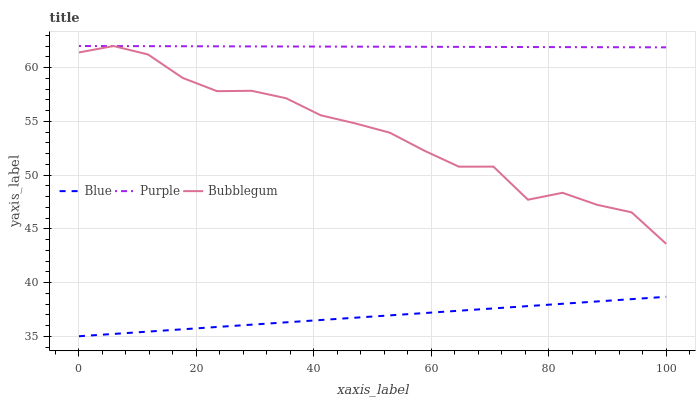Does Bubblegum have the minimum area under the curve?
Answer yes or no. No. Does Bubblegum have the maximum area under the curve?
Answer yes or no. No. Is Bubblegum the smoothest?
Answer yes or no. No. Is Purple the roughest?
Answer yes or no. No. Does Bubblegum have the lowest value?
Answer yes or no. No. Is Blue less than Purple?
Answer yes or no. Yes. Is Purple greater than Blue?
Answer yes or no. Yes. Does Blue intersect Purple?
Answer yes or no. No. 